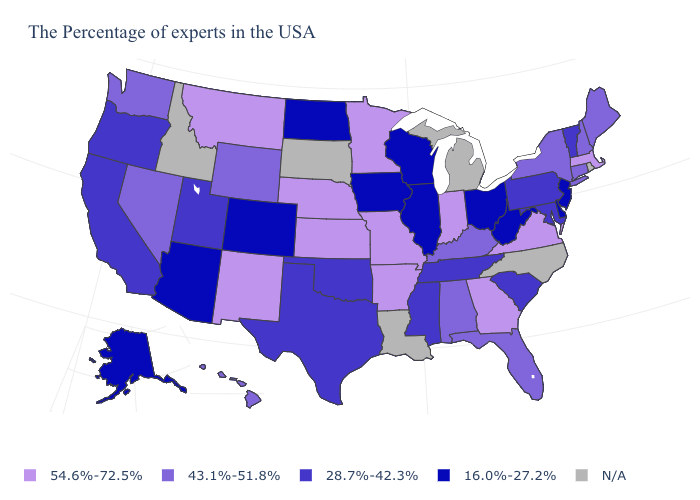Name the states that have a value in the range 16.0%-27.2%?
Write a very short answer. New Jersey, Delaware, West Virginia, Ohio, Wisconsin, Illinois, Iowa, North Dakota, Colorado, Arizona, Alaska. Name the states that have a value in the range 16.0%-27.2%?
Short answer required. New Jersey, Delaware, West Virginia, Ohio, Wisconsin, Illinois, Iowa, North Dakota, Colorado, Arizona, Alaska. Which states have the highest value in the USA?
Answer briefly. Massachusetts, Virginia, Georgia, Indiana, Missouri, Arkansas, Minnesota, Kansas, Nebraska, New Mexico, Montana. Which states have the lowest value in the MidWest?
Write a very short answer. Ohio, Wisconsin, Illinois, Iowa, North Dakota. What is the value of Kansas?
Keep it brief. 54.6%-72.5%. What is the value of South Carolina?
Answer briefly. 28.7%-42.3%. Name the states that have a value in the range 16.0%-27.2%?
Write a very short answer. New Jersey, Delaware, West Virginia, Ohio, Wisconsin, Illinois, Iowa, North Dakota, Colorado, Arizona, Alaska. Name the states that have a value in the range 54.6%-72.5%?
Write a very short answer. Massachusetts, Virginia, Georgia, Indiana, Missouri, Arkansas, Minnesota, Kansas, Nebraska, New Mexico, Montana. Among the states that border New Hampshire , which have the highest value?
Concise answer only. Massachusetts. Does New York have the lowest value in the Northeast?
Give a very brief answer. No. Is the legend a continuous bar?
Short answer required. No. Does the map have missing data?
Short answer required. Yes. Name the states that have a value in the range 16.0%-27.2%?
Give a very brief answer. New Jersey, Delaware, West Virginia, Ohio, Wisconsin, Illinois, Iowa, North Dakota, Colorado, Arizona, Alaska. Name the states that have a value in the range 54.6%-72.5%?
Quick response, please. Massachusetts, Virginia, Georgia, Indiana, Missouri, Arkansas, Minnesota, Kansas, Nebraska, New Mexico, Montana. 